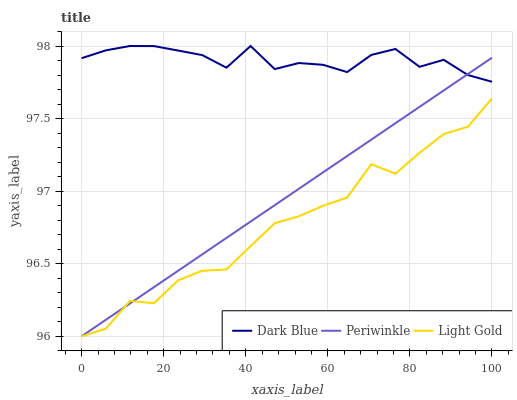Does Periwinkle have the minimum area under the curve?
Answer yes or no. No. Does Periwinkle have the maximum area under the curve?
Answer yes or no. No. Is Light Gold the smoothest?
Answer yes or no. No. Is Periwinkle the roughest?
Answer yes or no. No. Does Periwinkle have the highest value?
Answer yes or no. No. Is Light Gold less than Dark Blue?
Answer yes or no. Yes. Is Dark Blue greater than Light Gold?
Answer yes or no. Yes. Does Light Gold intersect Dark Blue?
Answer yes or no. No. 